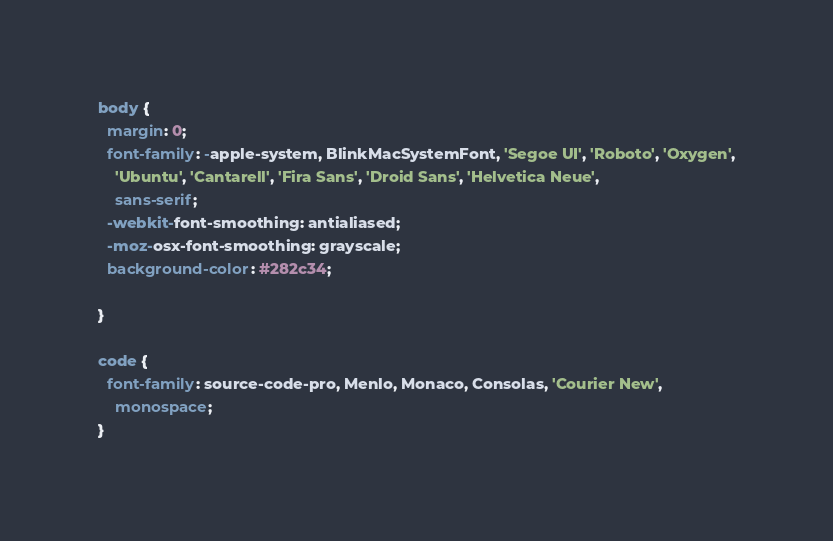Convert code to text. <code><loc_0><loc_0><loc_500><loc_500><_CSS_>body {
  margin: 0;
  font-family: -apple-system, BlinkMacSystemFont, 'Segoe UI', 'Roboto', 'Oxygen',
    'Ubuntu', 'Cantarell', 'Fira Sans', 'Droid Sans', 'Helvetica Neue',
    sans-serif;
  -webkit-font-smoothing: antialiased;
  -moz-osx-font-smoothing: grayscale;
  background-color: #282c34;

}

code {
  font-family: source-code-pro, Menlo, Monaco, Consolas, 'Courier New',
    monospace;
}
</code> 